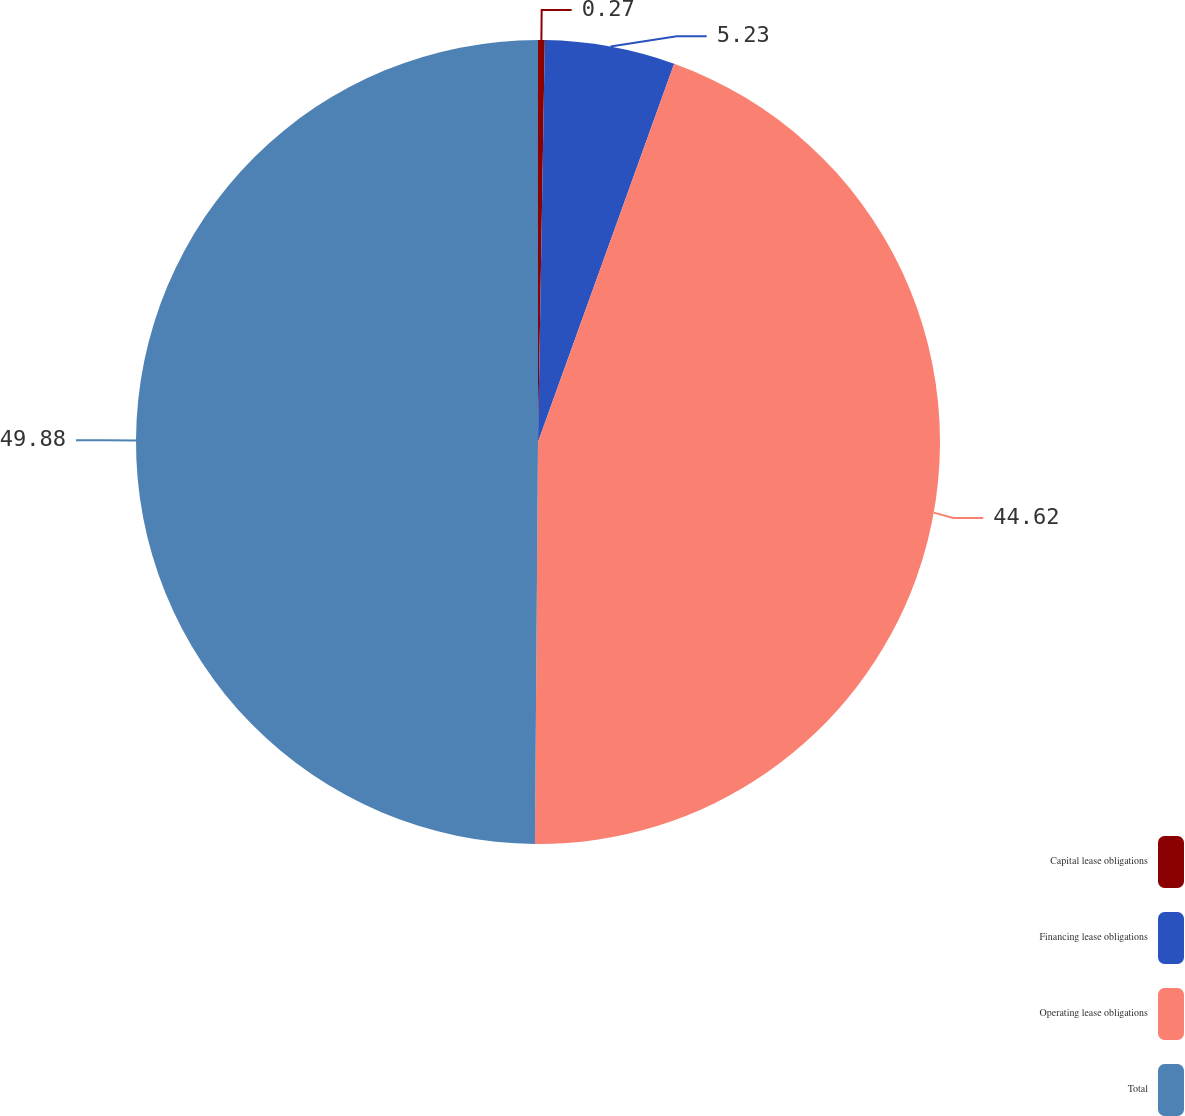Convert chart to OTSL. <chart><loc_0><loc_0><loc_500><loc_500><pie_chart><fcel>Capital lease obligations<fcel>Financing lease obligations<fcel>Operating lease obligations<fcel>Total<nl><fcel>0.27%<fcel>5.23%<fcel>44.62%<fcel>49.88%<nl></chart> 